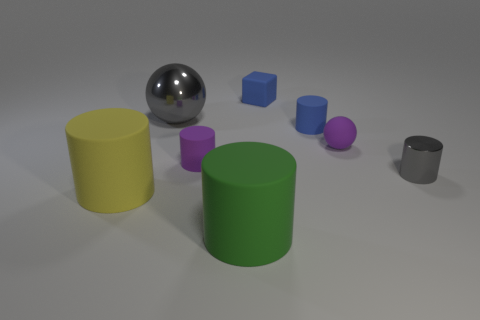Subtract 1 cylinders. How many cylinders are left? 4 Subtract all blue cylinders. How many cylinders are left? 4 Subtract all yellow cylinders. Subtract all cyan spheres. How many cylinders are left? 4 Add 1 gray shiny things. How many objects exist? 9 Subtract all balls. How many objects are left? 6 Add 2 green rubber objects. How many green rubber objects are left? 3 Add 1 gray spheres. How many gray spheres exist? 2 Subtract 1 purple balls. How many objects are left? 7 Subtract all small brown shiny objects. Subtract all shiny spheres. How many objects are left? 7 